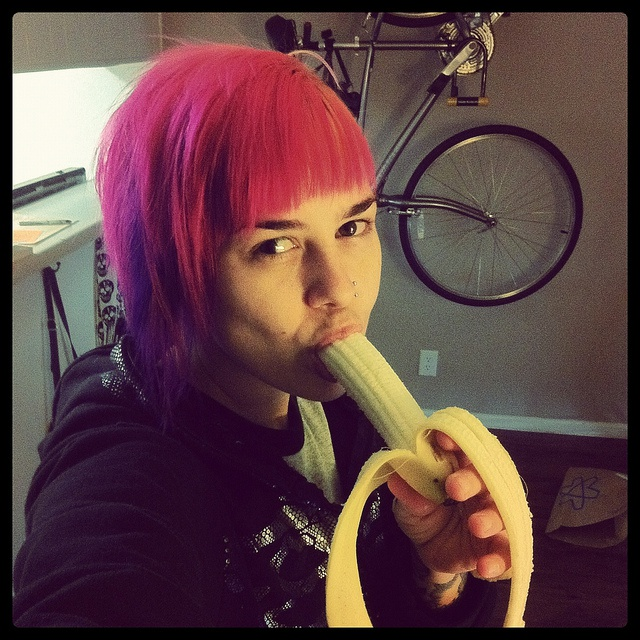Describe the objects in this image and their specific colors. I can see people in black, maroon, tan, and brown tones, bicycle in black and gray tones, banana in black, tan, khaki, and gray tones, and handbag in black and gray tones in this image. 